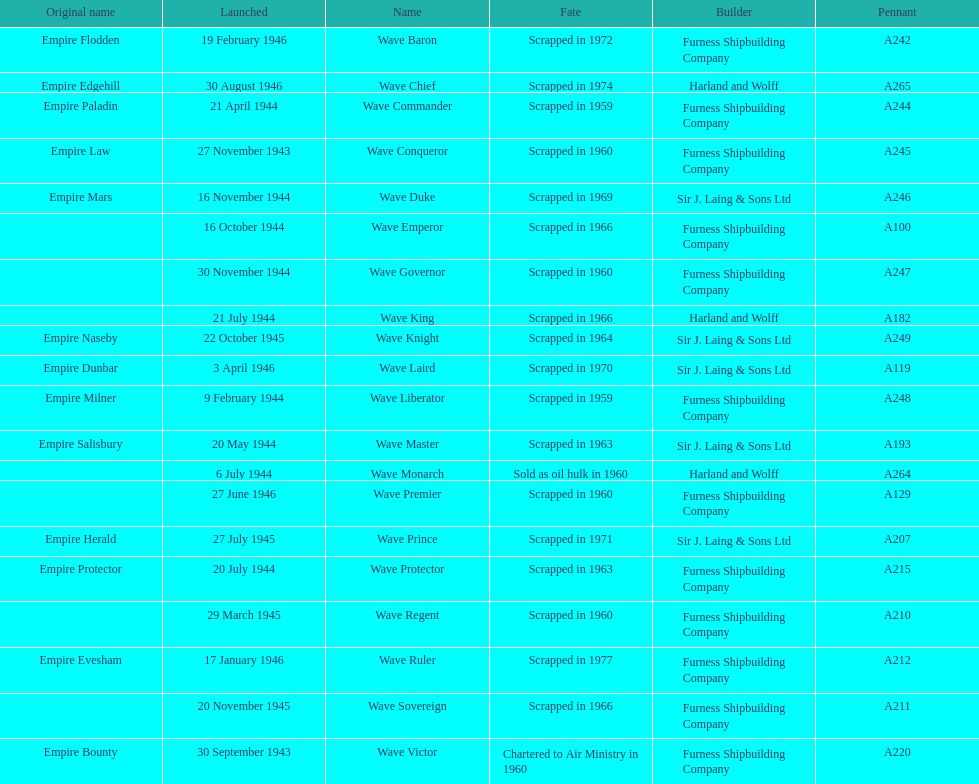Which other ship was launched in the same year as the wave victor? Wave Conqueror. 